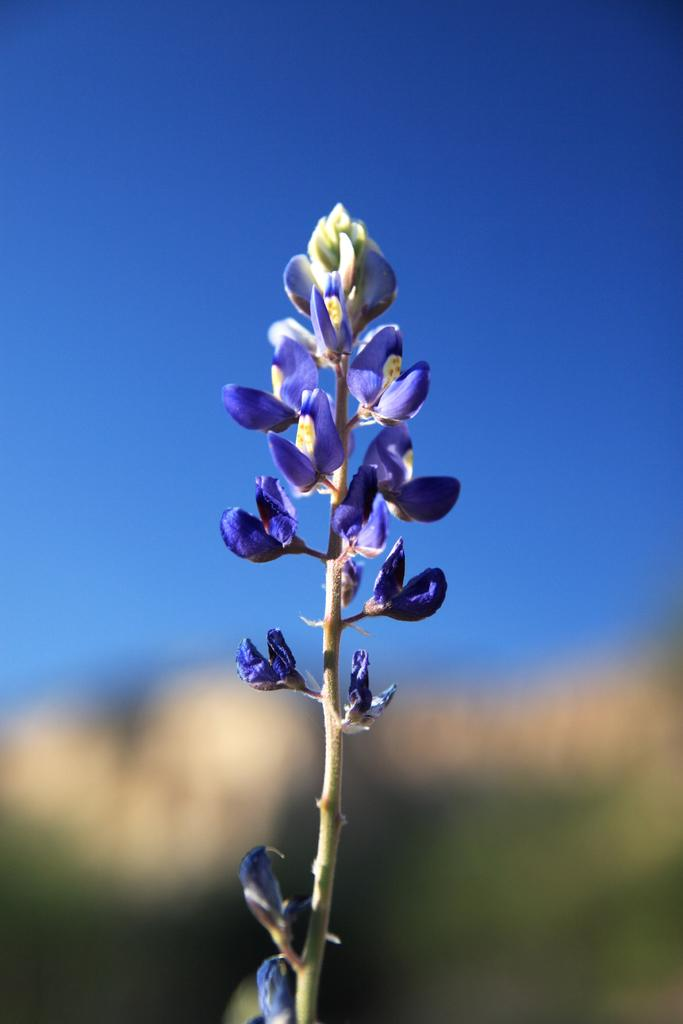What type of flower is in the image? There is a bluebonnet in the image. Can you describe the background of the image? The background of the image is blurred. What type of kettle is visible in the image? There is no kettle present in the image; it only features a bluebonnet and a blurred background. 